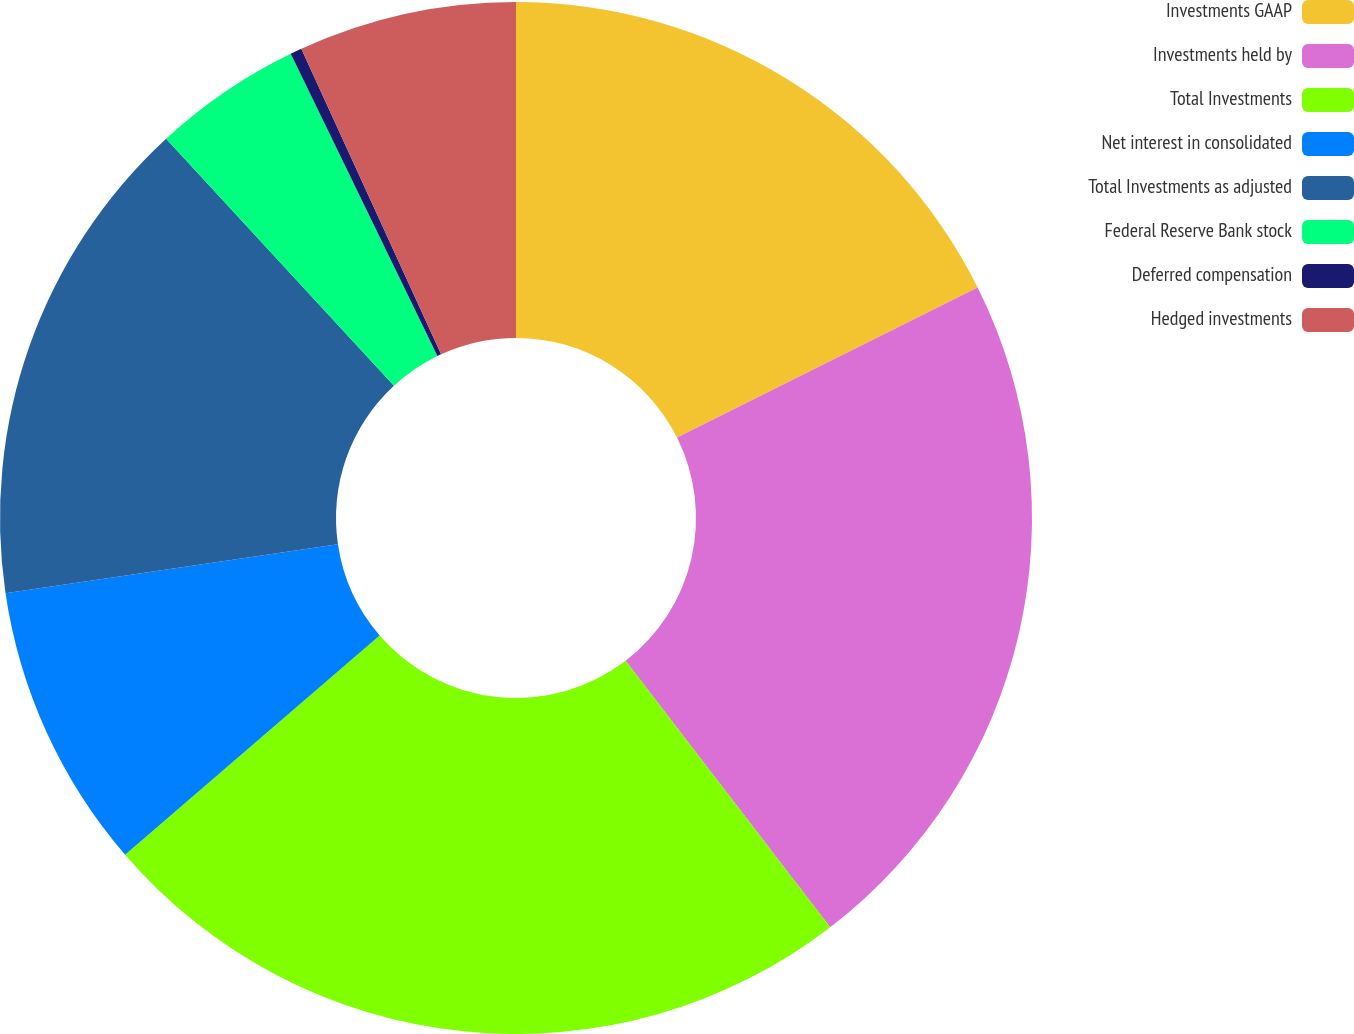Convert chart. <chart><loc_0><loc_0><loc_500><loc_500><pie_chart><fcel>Investments GAAP<fcel>Investments held by<fcel>Total Investments<fcel>Net interest in consolidated<fcel>Total Investments as adjusted<fcel>Federal Reserve Bank stock<fcel>Deferred compensation<fcel>Hedged investments<nl><fcel>17.63%<fcel>21.95%<fcel>24.1%<fcel>8.99%<fcel>15.47%<fcel>4.67%<fcel>0.36%<fcel>6.83%<nl></chart> 